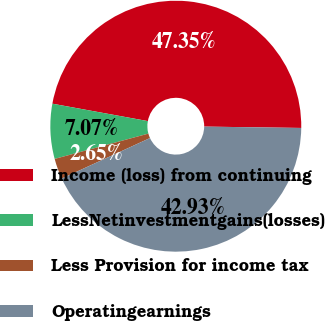<chart> <loc_0><loc_0><loc_500><loc_500><pie_chart><fcel>Income (loss) from continuing<fcel>LessNetinvestmentgains(losses)<fcel>Less Provision for income tax<fcel>Operatingearnings<nl><fcel>47.35%<fcel>7.07%<fcel>2.65%<fcel>42.93%<nl></chart> 